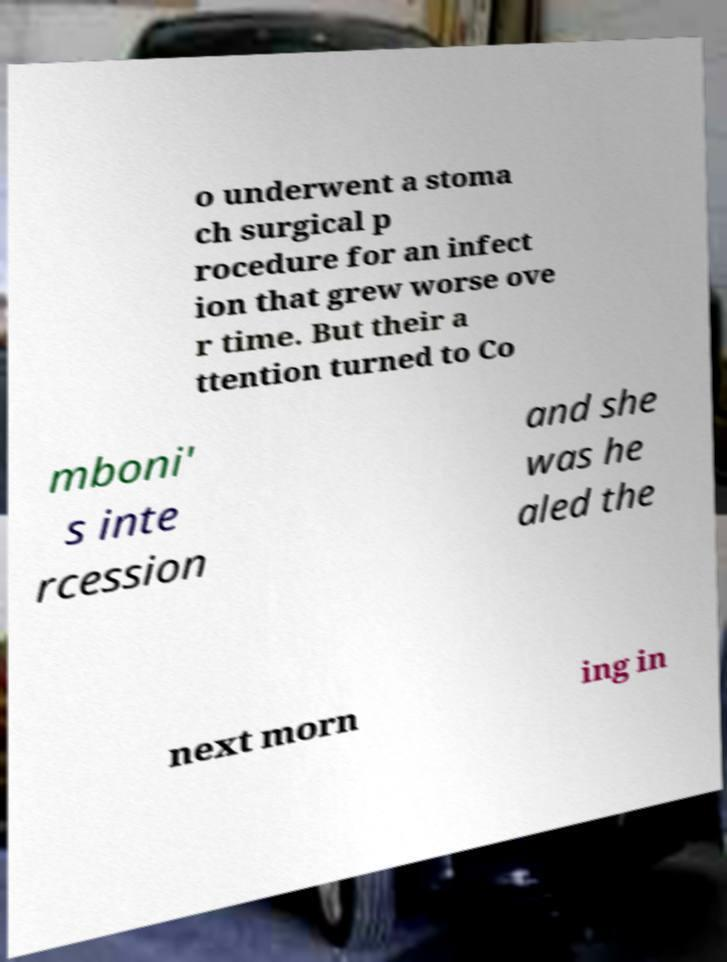Can you read and provide the text displayed in the image?This photo seems to have some interesting text. Can you extract and type it out for me? o underwent a stoma ch surgical p rocedure for an infect ion that grew worse ove r time. But their a ttention turned to Co mboni' s inte rcession and she was he aled the next morn ing in 